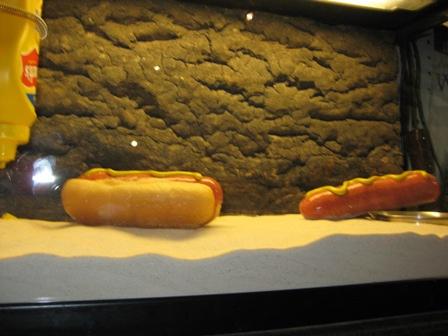What's the differences in the hot dogs?
Keep it brief. Bun. Would these be called jumbo franks?
Quick response, please. Yes. What are some of the toppings on the hot dog?
Concise answer only. Mustard. What is the bottle shown?
Write a very short answer. Mustard. 